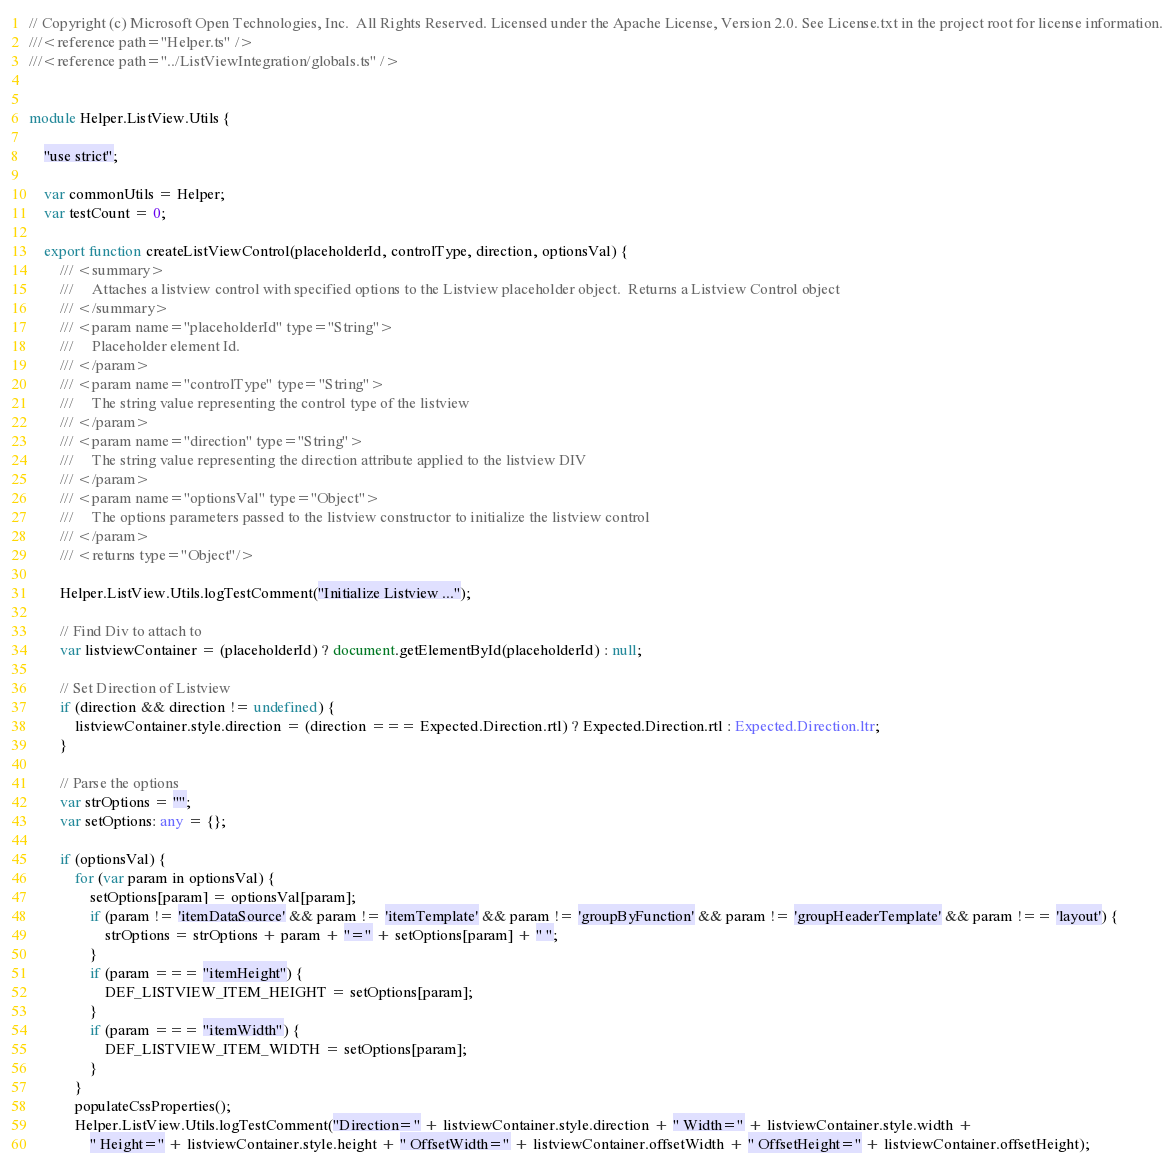<code> <loc_0><loc_0><loc_500><loc_500><_TypeScript_>// Copyright (c) Microsoft Open Technologies, Inc.  All Rights Reserved. Licensed under the Apache License, Version 2.0. See License.txt in the project root for license information.
///<reference path="Helper.ts" />
///<reference path="../ListViewIntegration/globals.ts" />


module Helper.ListView.Utils {

    "use strict";

    var commonUtils = Helper;
    var testCount = 0;

    export function createListViewControl(placeholderId, controlType, direction, optionsVal) {
        /// <summary>
        ///     Attaches a listview control with specified options to the Listview placeholder object.  Returns a Listview Control object
        /// </summary>
        /// <param name="placeholderId" type="String">
        ///     Placeholder element Id.
        /// </param>
        /// <param name="controlType" type="String">
        ///     The string value representing the control type of the listview
        /// </param>
        /// <param name="direction" type="String">
        ///     The string value representing the direction attribute applied to the listview DIV
        /// </param>
        /// <param name="optionsVal" type="Object">
        ///     The options parameters passed to the listview constructor to initialize the listview control
        /// </param>
        /// <returns type="Object"/>

        Helper.ListView.Utils.logTestComment("Initialize Listview ...");

        // Find Div to attach to
        var listviewContainer = (placeholderId) ? document.getElementById(placeholderId) : null;

        // Set Direction of Listview
        if (direction && direction != undefined) {
            listviewContainer.style.direction = (direction === Expected.Direction.rtl) ? Expected.Direction.rtl : Expected.Direction.ltr;
        }

        // Parse the options
        var strOptions = "";
        var setOptions: any = {};

        if (optionsVal) {
            for (var param in optionsVal) {
                setOptions[param] = optionsVal[param];
                if (param != 'itemDataSource' && param != 'itemTemplate' && param != 'groupByFunction' && param != 'groupHeaderTemplate' && param !== 'layout') {
                    strOptions = strOptions + param + "=" + setOptions[param] + " ";
                }
                if (param === "itemHeight") {
                    DEF_LISTVIEW_ITEM_HEIGHT = setOptions[param];
                }
                if (param === "itemWidth") {
                    DEF_LISTVIEW_ITEM_WIDTH = setOptions[param];
                }
            }
            populateCssProperties();
            Helper.ListView.Utils.logTestComment("Direction=" + listviewContainer.style.direction + " Width=" + listviewContainer.style.width +
                " Height=" + listviewContainer.style.height + " OffsetWidth=" + listviewContainer.offsetWidth + " OffsetHeight=" + listviewContainer.offsetHeight);</code> 